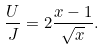<formula> <loc_0><loc_0><loc_500><loc_500>\frac { U } { J } = 2 \frac { x - 1 } { \sqrt { x } } .</formula> 